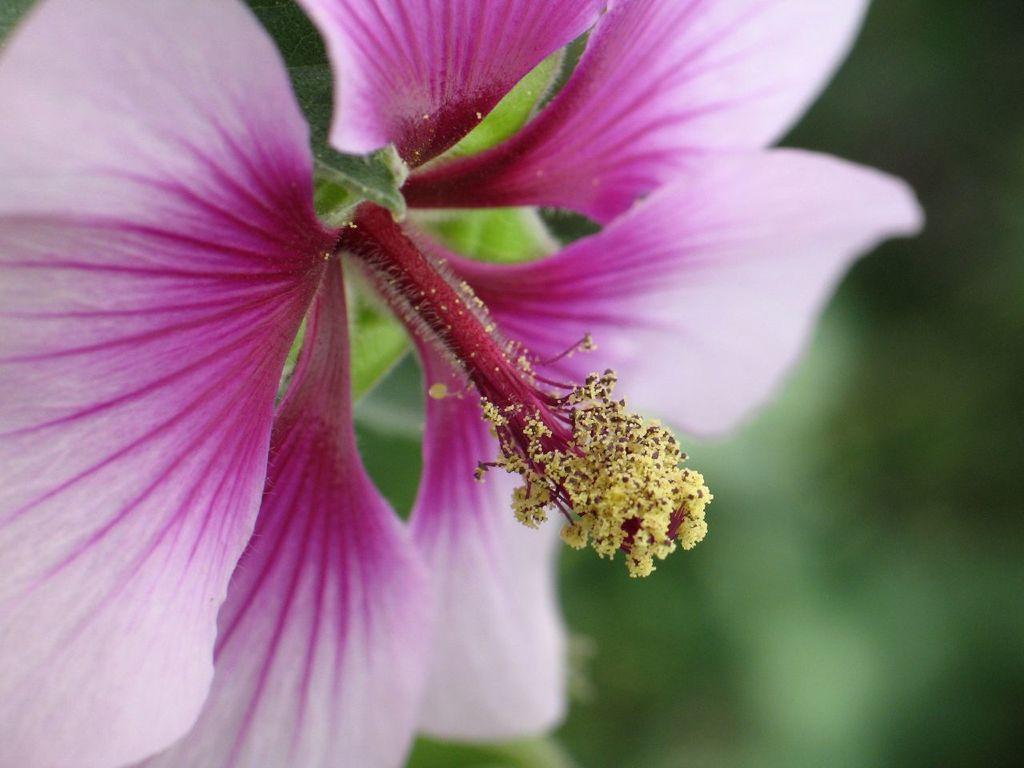In one or two sentences, can you explain what this image depicts? In this image I can see a pink colour flower in the front and I can see this image is blurry in the background. I can also see green colour background. 